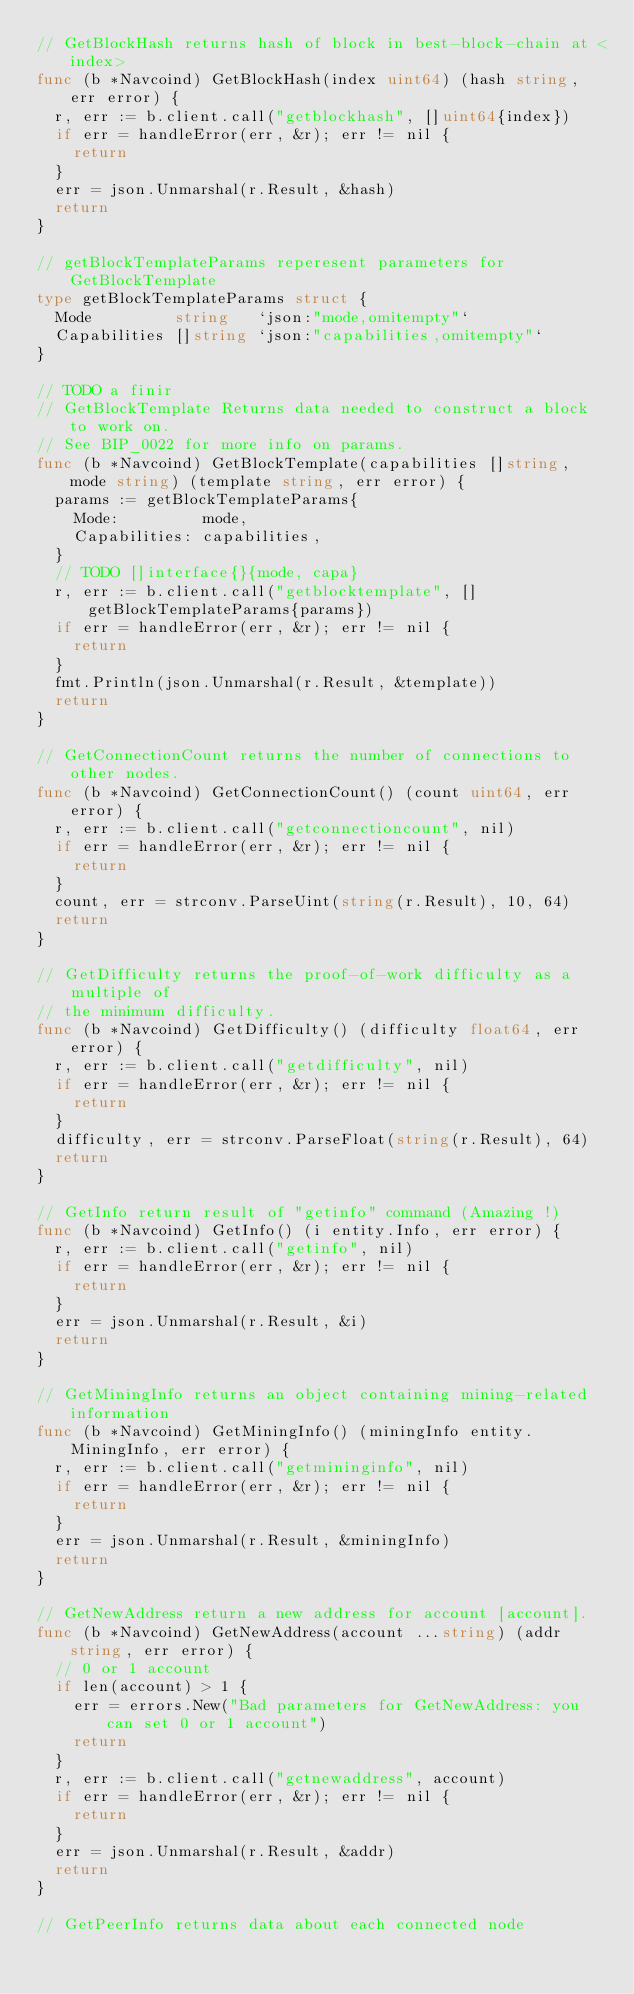<code> <loc_0><loc_0><loc_500><loc_500><_Go_>// GetBlockHash returns hash of block in best-block-chain at <index>
func (b *Navcoind) GetBlockHash(index uint64) (hash string, err error) {
	r, err := b.client.call("getblockhash", []uint64{index})
	if err = handleError(err, &r); err != nil {
		return
	}
	err = json.Unmarshal(r.Result, &hash)
	return
}

// getBlockTemplateParams reperesent parameters for GetBlockTemplate
type getBlockTemplateParams struct {
	Mode         string   `json:"mode,omitempty"`
	Capabilities []string `json:"capabilities,omitempty"`
}

// TODO a finir
// GetBlockTemplate Returns data needed to construct a block to work on.
// See BIP_0022 for more info on params.
func (b *Navcoind) GetBlockTemplate(capabilities []string, mode string) (template string, err error) {
	params := getBlockTemplateParams{
		Mode:         mode,
		Capabilities: capabilities,
	}
	// TODO []interface{}{mode, capa}
	r, err := b.client.call("getblocktemplate", []getBlockTemplateParams{params})
	if err = handleError(err, &r); err != nil {
		return
	}
	fmt.Println(json.Unmarshal(r.Result, &template))
	return
}

// GetConnectionCount returns the number of connections to other nodes.
func (b *Navcoind) GetConnectionCount() (count uint64, err error) {
	r, err := b.client.call("getconnectioncount", nil)
	if err = handleError(err, &r); err != nil {
		return
	}
	count, err = strconv.ParseUint(string(r.Result), 10, 64)
	return
}

// GetDifficulty returns the proof-of-work difficulty as a multiple of
// the minimum difficulty.
func (b *Navcoind) GetDifficulty() (difficulty float64, err error) {
	r, err := b.client.call("getdifficulty", nil)
	if err = handleError(err, &r); err != nil {
		return
	}
	difficulty, err = strconv.ParseFloat(string(r.Result), 64)
	return
}

// GetInfo return result of "getinfo" command (Amazing !)
func (b *Navcoind) GetInfo() (i entity.Info, err error) {
	r, err := b.client.call("getinfo", nil)
	if err = handleError(err, &r); err != nil {
		return
	}
	err = json.Unmarshal(r.Result, &i)
	return
}

// GetMiningInfo returns an object containing mining-related information
func (b *Navcoind) GetMiningInfo() (miningInfo entity.MiningInfo, err error) {
	r, err := b.client.call("getmininginfo", nil)
	if err = handleError(err, &r); err != nil {
		return
	}
	err = json.Unmarshal(r.Result, &miningInfo)
	return
}

// GetNewAddress return a new address for account [account].
func (b *Navcoind) GetNewAddress(account ...string) (addr string, err error) {
	// 0 or 1 account
	if len(account) > 1 {
		err = errors.New("Bad parameters for GetNewAddress: you can set 0 or 1 account")
		return
	}
	r, err := b.client.call("getnewaddress", account)
	if err = handleError(err, &r); err != nil {
		return
	}
	err = json.Unmarshal(r.Result, &addr)
	return
}

// GetPeerInfo returns data about each connected node</code> 